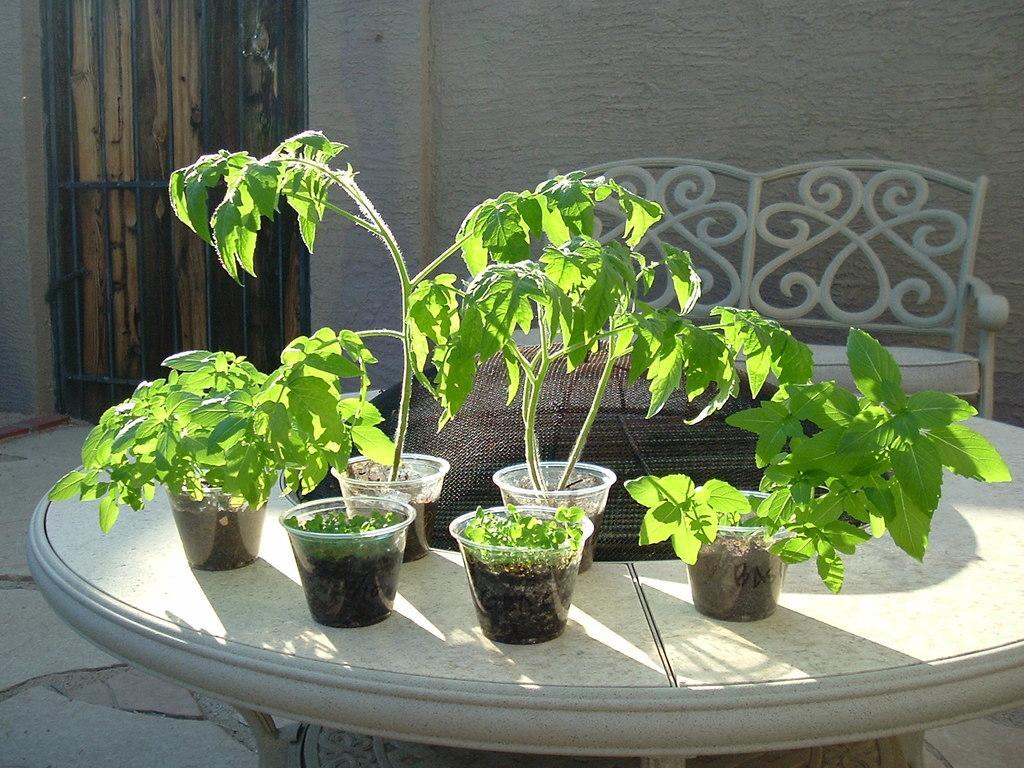How would you summarize this image in a sentence or two? This image consists of potted plants kept on a table. At the bottom, there is a floor. In the background, we can see a chair. On the left, there is a door made up of wood. 